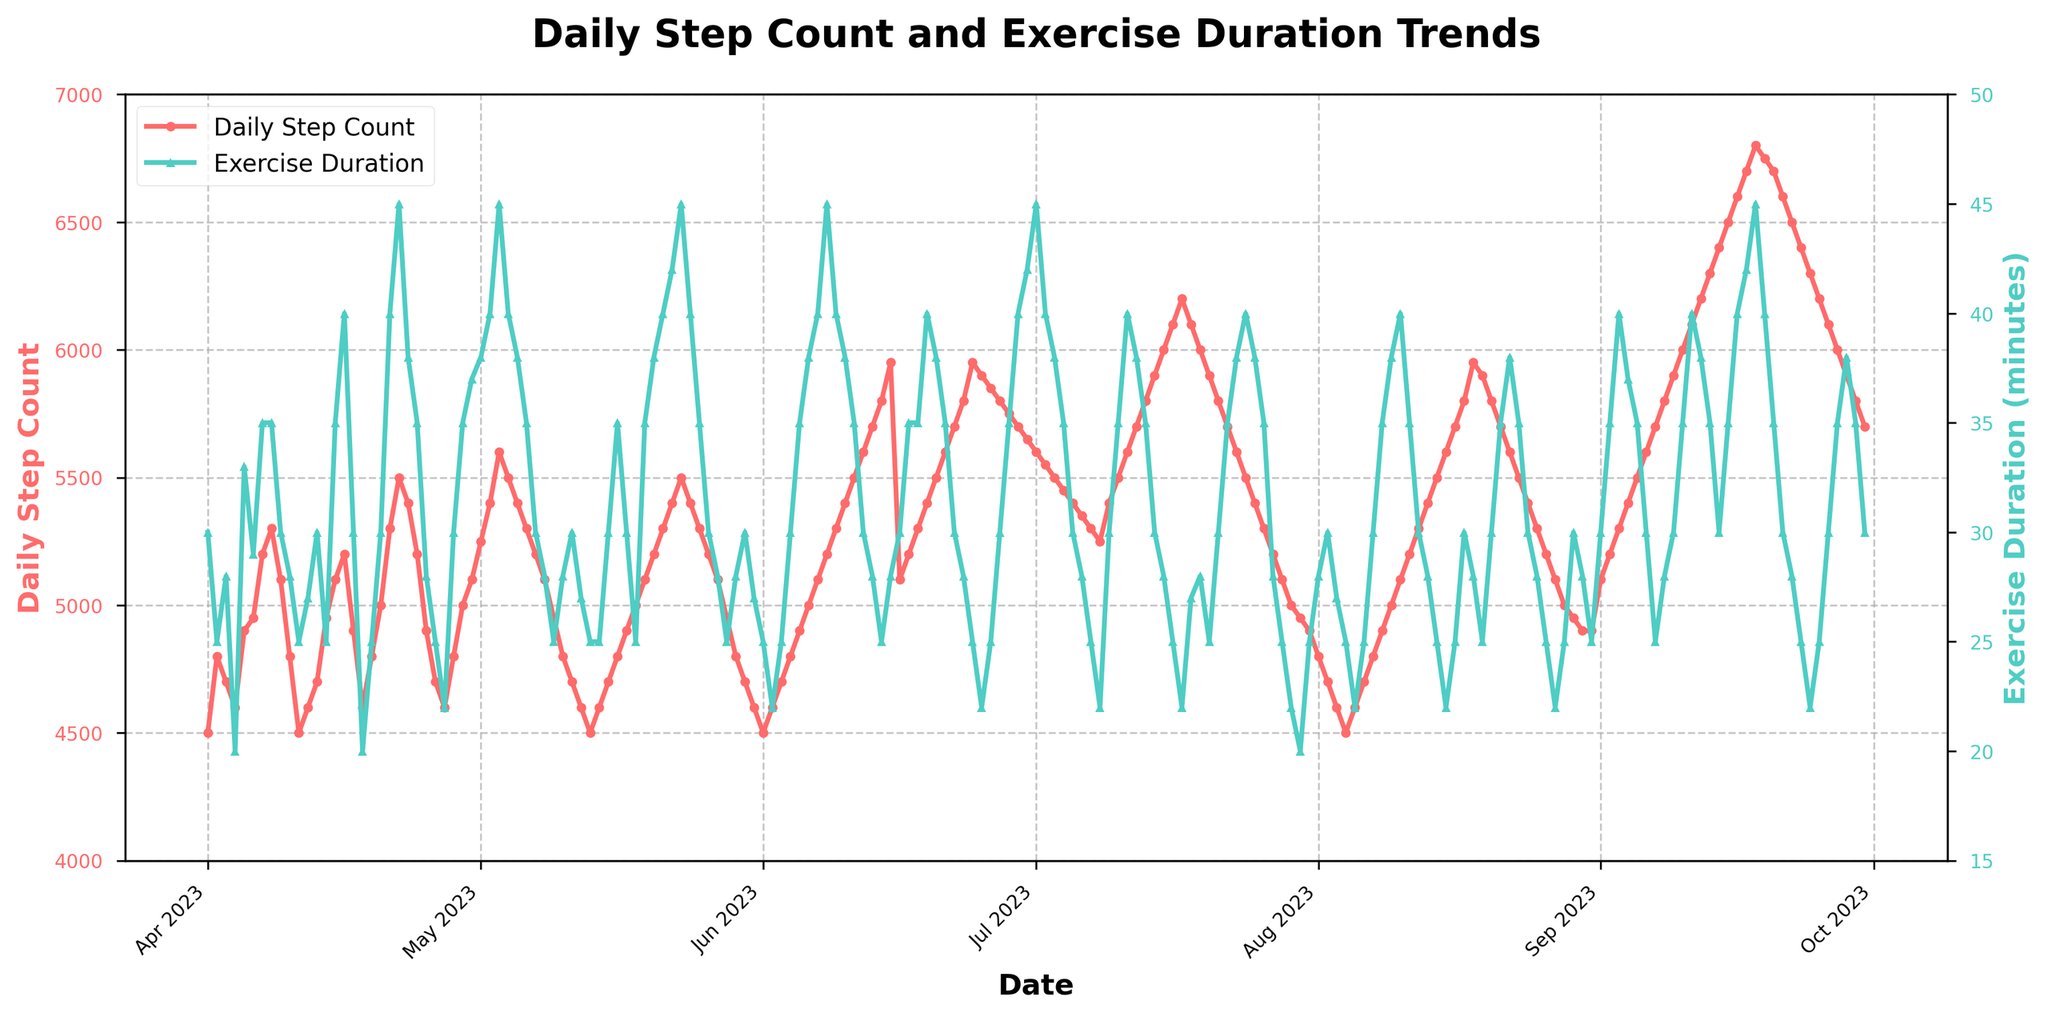What is the title of the plot? The title is clearly indicated at the top of the figure.
Answer: Daily Step Count and Exercise Duration Trends What are the units on the y-axes for the plot? The plot has two y-axes: one on the left for "Daily Step Count" measured in steps, and one on the right for "Exercise Duration" measured in minutes.
Answer: Steps and Minutes How does the trend in daily step count change from April to September? To understand the trend, look at the plot lines for each month from April to September. The trend shows an overall increase in daily step count over this period.
Answer: Increasing Which month has the highest average exercise duration? To determine the month with the highest average exercise duration, observe the exercise duration plot and compare the average duration for each month. September shows the highest average exercise duration.
Answer: September Does the exercise duration show any visible seasonality within the six months? By looking at the exercise duration plot, I can check for recurring patterns or fluctuations over the months. Exercise duration is higher in summer months (June to September) and lower in spring (April and May).
Answer: Yes On which date was the highest number of steps recorded, and how many steps were taken? Look along the daily step count plot to find the peak point, which is on September 18th with 6800 steps.
Answer: September 18th, 6800 steps Is there any particular point where both the daily step count and exercise duration are at their peak on the same date? Compare the peaks of both the step count and exercise duration plots. There is no date where both metrics peak simultaneously.
Answer: No From May to June, is the average daily step count greater than the average exercise duration in minutes? Calculate the average daily steps and exercise minutes for May and June. The average daily steps are roughly higher compared to exercise duration.
Answer: Yes What is the general relationship between daily step count and exercise duration over the given period? Evaluate the plot to identify if there is any correlation between the step count and exercise duration trends. Both metrics tend to increase together, indicating a positive correlation.
Answer: Positive correlation 